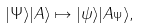Convert formula to latex. <formula><loc_0><loc_0><loc_500><loc_500>| \Psi \rangle | A \rangle \mapsto | \psi \rangle | A _ { \Psi } \rangle , \,</formula> 